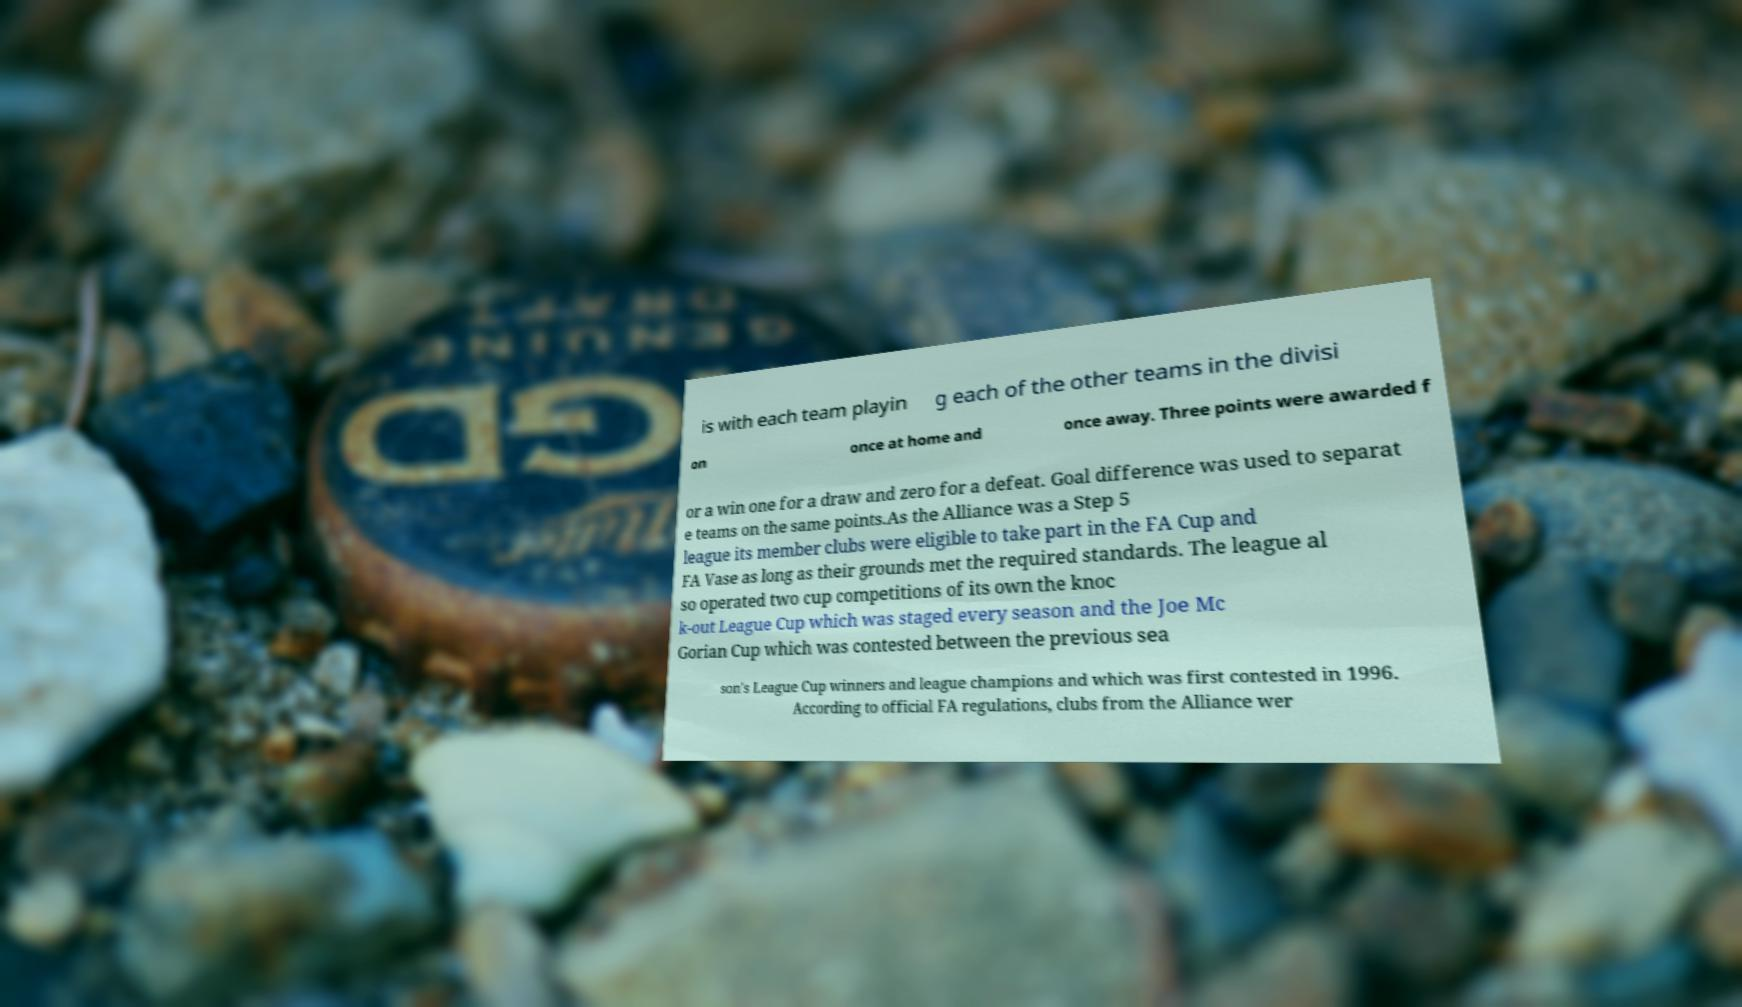Please identify and transcribe the text found in this image. is with each team playin g each of the other teams in the divisi on once at home and once away. Three points were awarded f or a win one for a draw and zero for a defeat. Goal difference was used to separat e teams on the same points.As the Alliance was a Step 5 league its member clubs were eligible to take part in the FA Cup and FA Vase as long as their grounds met the required standards. The league al so operated two cup competitions of its own the knoc k-out League Cup which was staged every season and the Joe Mc Gorian Cup which was contested between the previous sea son's League Cup winners and league champions and which was first contested in 1996. According to official FA regulations, clubs from the Alliance wer 